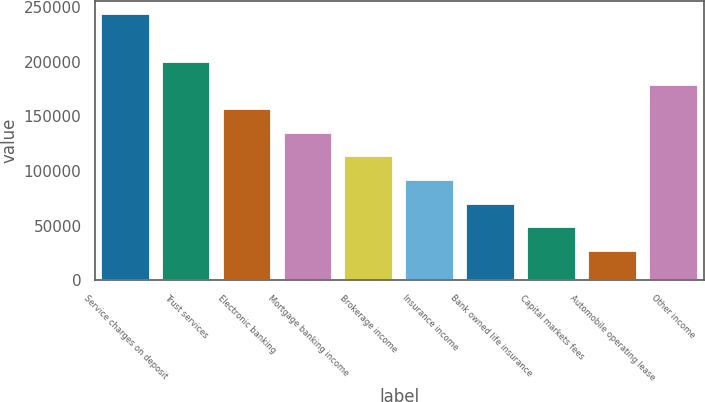Convert chart to OTSL. <chart><loc_0><loc_0><loc_500><loc_500><bar_chart><fcel>Service charges on deposit<fcel>Trust services<fcel>Electronic banking<fcel>Mortgage banking income<fcel>Brokerage income<fcel>Insurance income<fcel>Bank owned life insurance<fcel>Capital markets fees<fcel>Automobile operating lease<fcel>Other income<nl><fcel>243507<fcel>200160<fcel>156813<fcel>135139<fcel>113465<fcel>91791.8<fcel>70118.2<fcel>48444.6<fcel>26771<fcel>178486<nl></chart> 